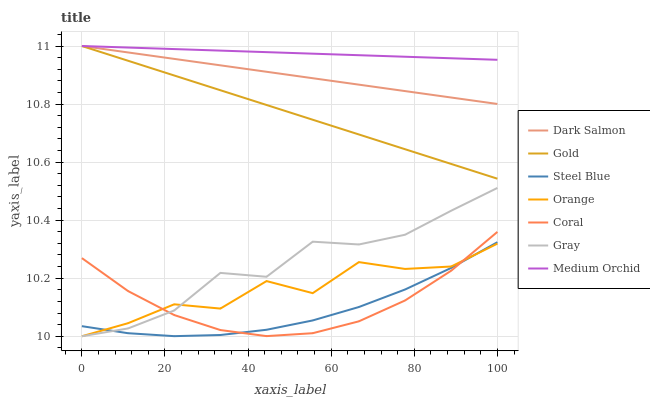Does Steel Blue have the minimum area under the curve?
Answer yes or no. Yes. Does Medium Orchid have the maximum area under the curve?
Answer yes or no. Yes. Does Gold have the minimum area under the curve?
Answer yes or no. No. Does Gold have the maximum area under the curve?
Answer yes or no. No. Is Medium Orchid the smoothest?
Answer yes or no. Yes. Is Orange the roughest?
Answer yes or no. Yes. Is Gold the smoothest?
Answer yes or no. No. Is Gold the roughest?
Answer yes or no. No. Does Gray have the lowest value?
Answer yes or no. Yes. Does Gold have the lowest value?
Answer yes or no. No. Does Dark Salmon have the highest value?
Answer yes or no. Yes. Does Coral have the highest value?
Answer yes or no. No. Is Coral less than Dark Salmon?
Answer yes or no. Yes. Is Gold greater than Orange?
Answer yes or no. Yes. Does Coral intersect Orange?
Answer yes or no. Yes. Is Coral less than Orange?
Answer yes or no. No. Is Coral greater than Orange?
Answer yes or no. No. Does Coral intersect Dark Salmon?
Answer yes or no. No. 